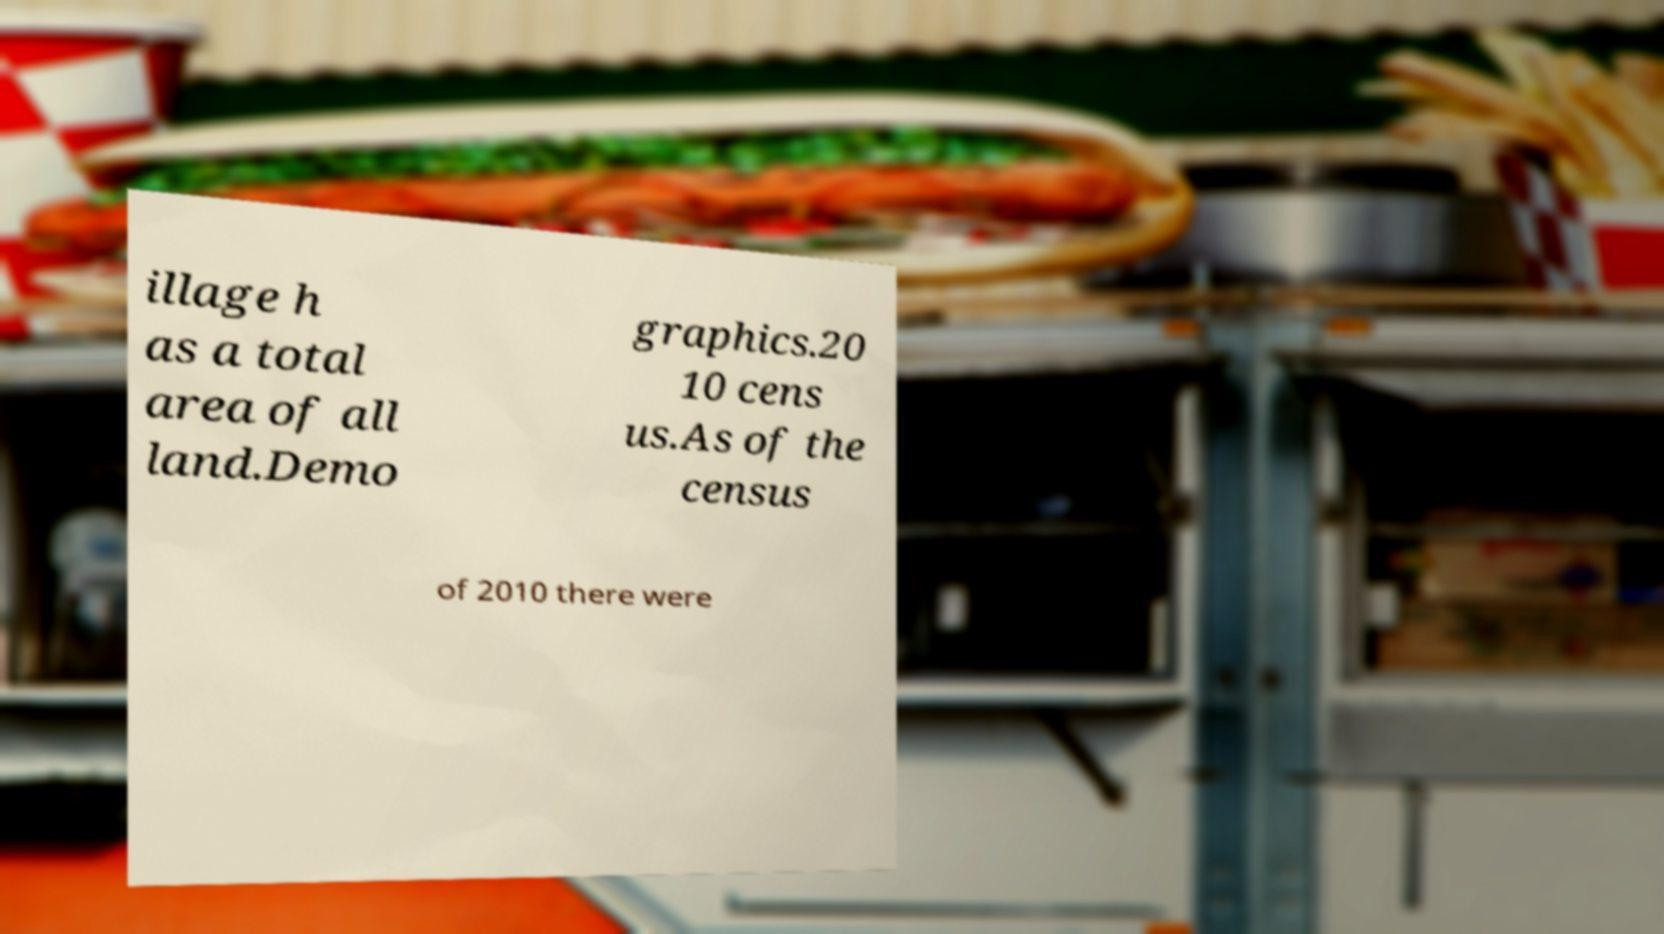There's text embedded in this image that I need extracted. Can you transcribe it verbatim? illage h as a total area of all land.Demo graphics.20 10 cens us.As of the census of 2010 there were 